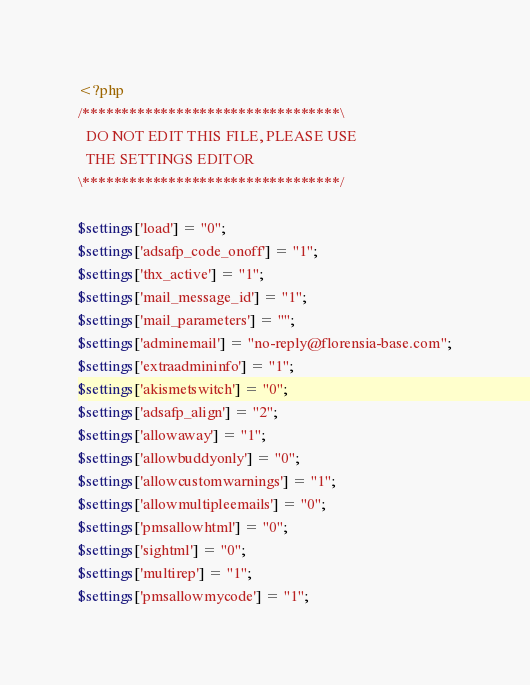Convert code to text. <code><loc_0><loc_0><loc_500><loc_500><_PHP_><?php
/*********************************\ 
  DO NOT EDIT THIS FILE, PLEASE USE
  THE SETTINGS EDITOR
\*********************************/

$settings['load'] = "0";
$settings['adsafp_code_onoff'] = "1";
$settings['thx_active'] = "1";
$settings['mail_message_id'] = "1";
$settings['mail_parameters'] = "";
$settings['adminemail'] = "no-reply@florensia-base.com";
$settings['extraadmininfo'] = "1";
$settings['akismetswitch'] = "0";
$settings['adsafp_align'] = "2";
$settings['allowaway'] = "1";
$settings['allowbuddyonly'] = "0";
$settings['allowcustomwarnings'] = "1";
$settings['allowmultipleemails'] = "0";
$settings['pmsallowhtml'] = "0";
$settings['sightml'] = "0";
$settings['multirep'] = "1";
$settings['pmsallowmycode'] = "1";</code> 